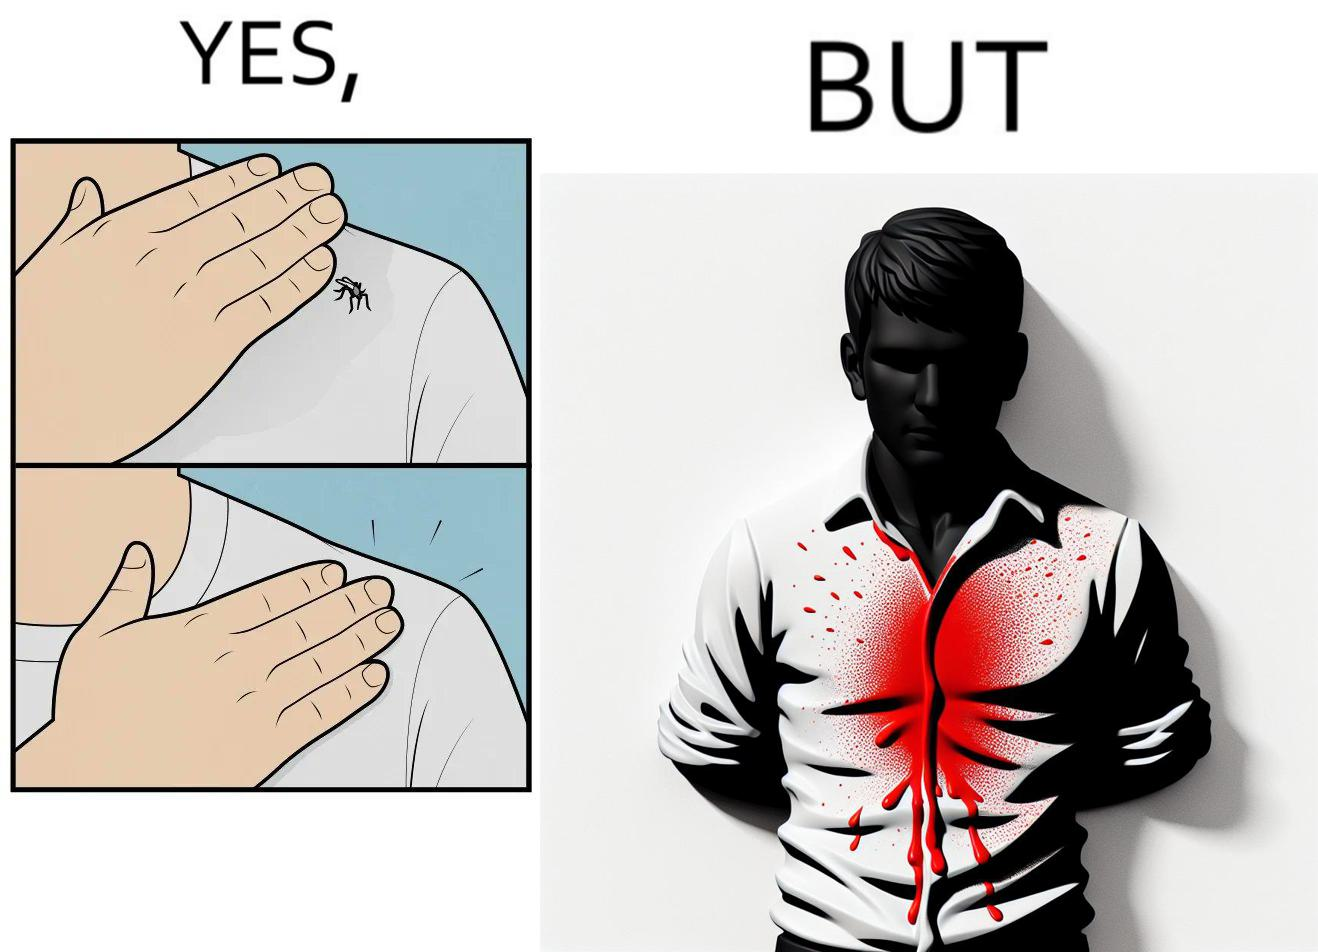What is the satirical meaning behind this image? The images are funny since a man trying to reduce his irritation by killing a mosquito bothering  him only causes himself more irritation by soiling his t-shirt with the mosquito blood 